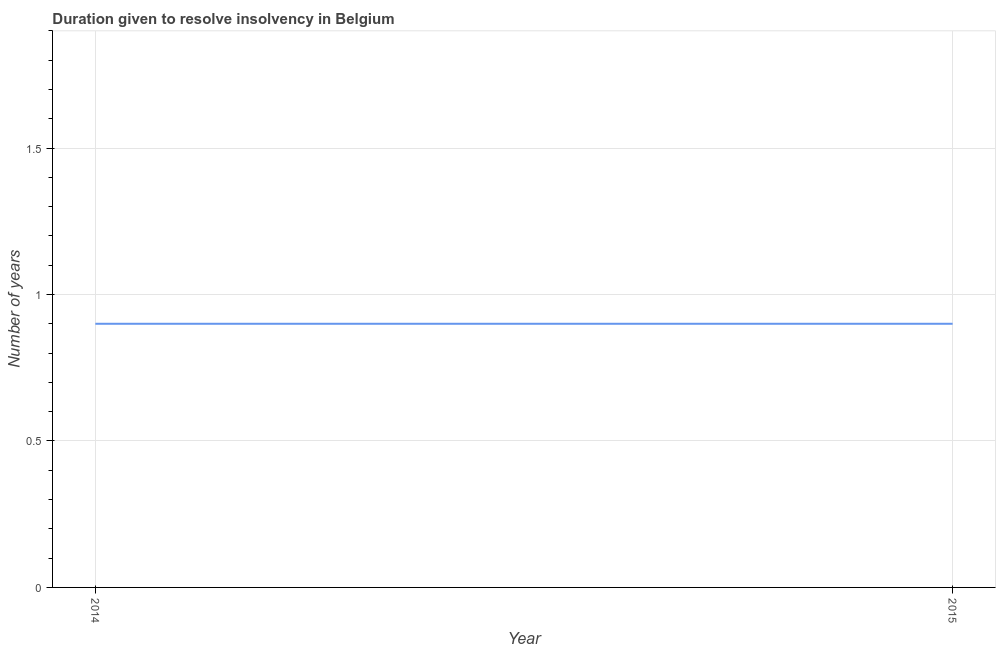What is the number of years to resolve insolvency in 2015?
Offer a very short reply. 0.9. Across all years, what is the maximum number of years to resolve insolvency?
Make the answer very short. 0.9. In which year was the number of years to resolve insolvency maximum?
Your answer should be very brief. 2014. What is the difference between the number of years to resolve insolvency in 2014 and 2015?
Offer a terse response. 0. What is the average number of years to resolve insolvency per year?
Provide a succinct answer. 0.9. What is the median number of years to resolve insolvency?
Your response must be concise. 0.9. In how many years, is the number of years to resolve insolvency greater than 0.5 ?
Make the answer very short. 2. Do a majority of the years between 2015 and 2014 (inclusive) have number of years to resolve insolvency greater than 0.1 ?
Make the answer very short. No. Is the number of years to resolve insolvency in 2014 less than that in 2015?
Make the answer very short. No. Does the number of years to resolve insolvency monotonically increase over the years?
Provide a succinct answer. No. How many lines are there?
Your answer should be compact. 1. How many years are there in the graph?
Keep it short and to the point. 2. What is the difference between two consecutive major ticks on the Y-axis?
Offer a terse response. 0.5. Does the graph contain grids?
Your answer should be compact. Yes. What is the title of the graph?
Make the answer very short. Duration given to resolve insolvency in Belgium. What is the label or title of the X-axis?
Offer a terse response. Year. What is the label or title of the Y-axis?
Offer a very short reply. Number of years. What is the Number of years of 2014?
Give a very brief answer. 0.9. What is the Number of years in 2015?
Your answer should be compact. 0.9. What is the difference between the Number of years in 2014 and 2015?
Your answer should be very brief. 0. 